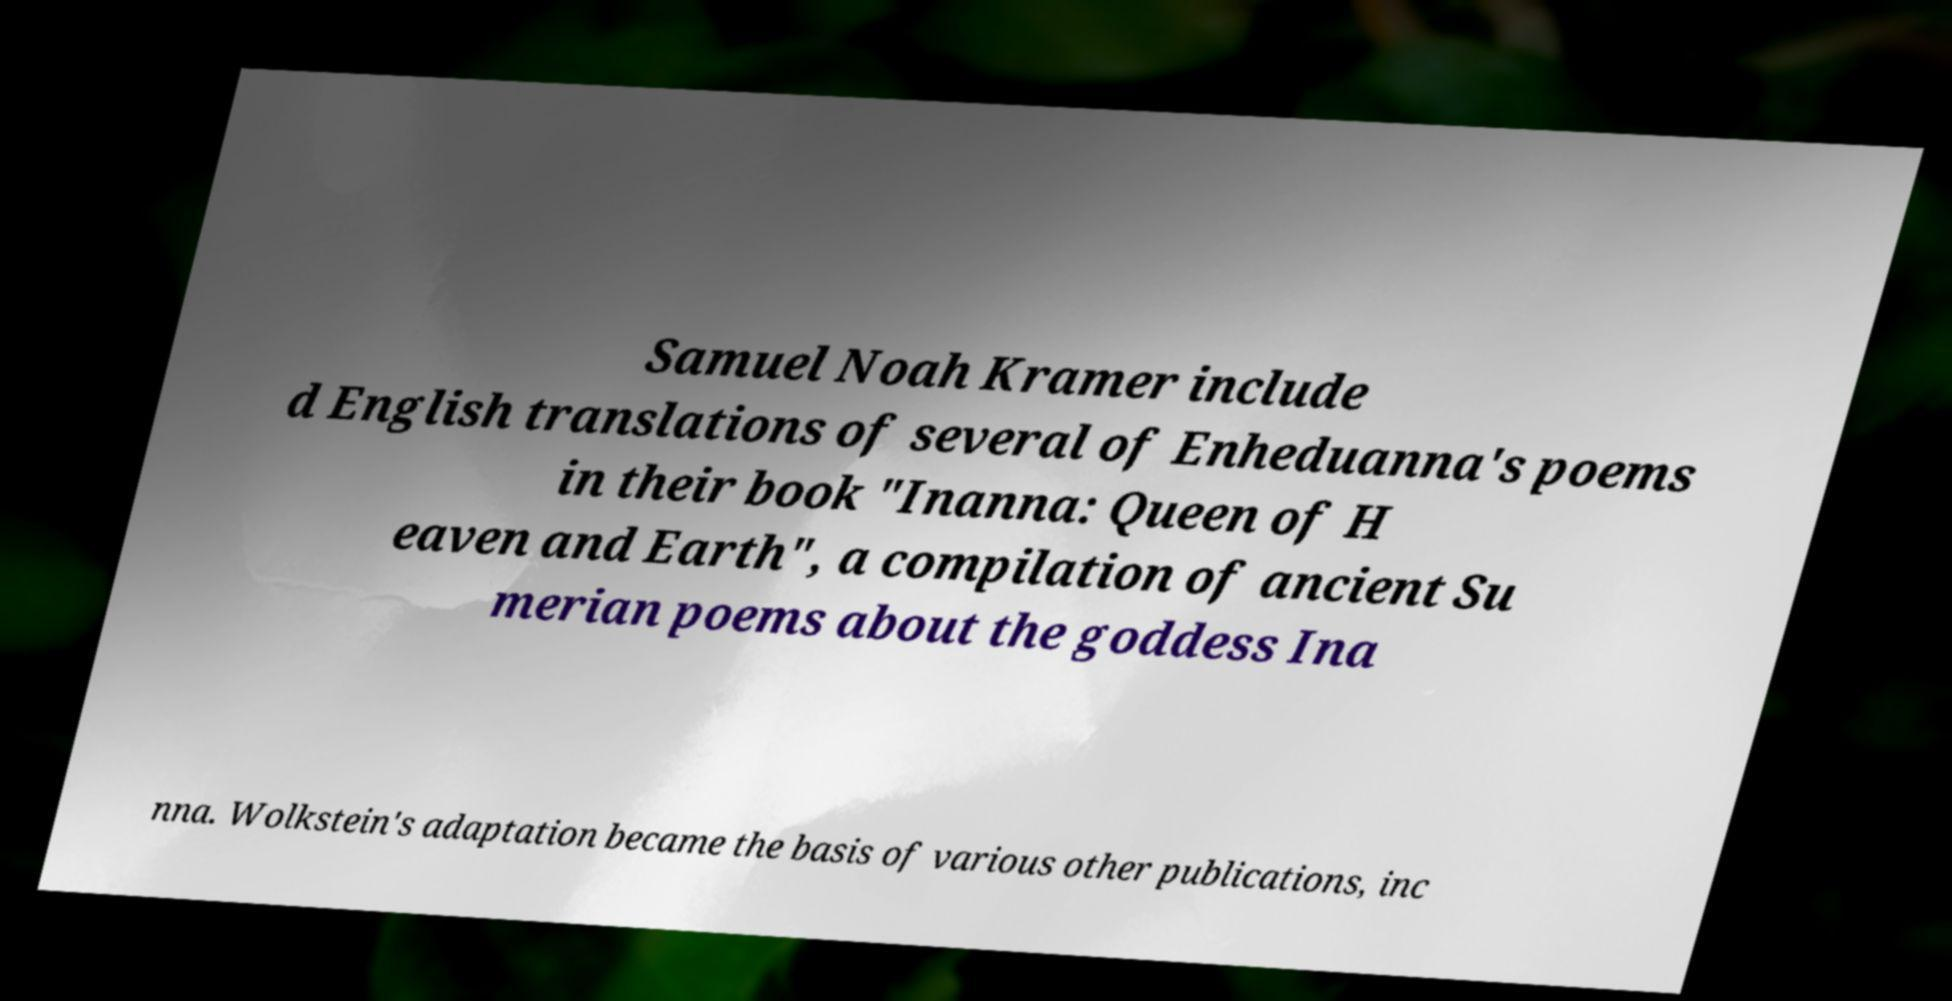Can you accurately transcribe the text from the provided image for me? Samuel Noah Kramer include d English translations of several of Enheduanna's poems in their book "Inanna: Queen of H eaven and Earth", a compilation of ancient Su merian poems about the goddess Ina nna. Wolkstein's adaptation became the basis of various other publications, inc 